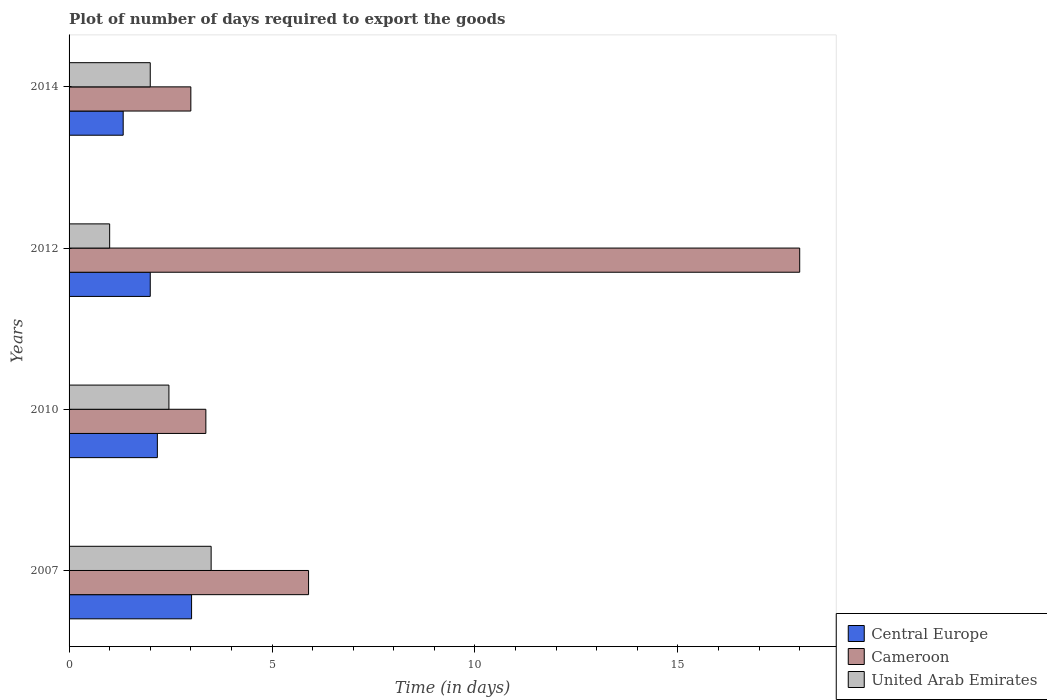Are the number of bars per tick equal to the number of legend labels?
Your response must be concise. Yes. How many bars are there on the 3rd tick from the top?
Your response must be concise. 3. How many bars are there on the 1st tick from the bottom?
Ensure brevity in your answer.  3. What is the label of the 1st group of bars from the top?
Offer a very short reply. 2014. In how many cases, is the number of bars for a given year not equal to the number of legend labels?
Provide a short and direct response. 0. What is the time required to export goods in Central Europe in 2010?
Your answer should be very brief. 2.17. In which year was the time required to export goods in Cameroon maximum?
Your answer should be compact. 2012. In which year was the time required to export goods in United Arab Emirates minimum?
Your answer should be compact. 2012. What is the total time required to export goods in United Arab Emirates in the graph?
Your response must be concise. 8.96. What is the difference between the time required to export goods in United Arab Emirates in 2007 and that in 2010?
Provide a succinct answer. 1.04. What is the difference between the time required to export goods in Central Europe in 2014 and the time required to export goods in Cameroon in 2007?
Keep it short and to the point. -4.57. What is the average time required to export goods in Central Europe per year?
Keep it short and to the point. 2.13. In the year 2014, what is the difference between the time required to export goods in Central Europe and time required to export goods in United Arab Emirates?
Your response must be concise. -0.67. What is the ratio of the time required to export goods in Cameroon in 2007 to that in 2010?
Provide a short and direct response. 1.75. Is the time required to export goods in Cameroon in 2010 less than that in 2012?
Your response must be concise. Yes. What is the difference between the highest and the second highest time required to export goods in United Arab Emirates?
Your answer should be compact. 1.04. What is the difference between the highest and the lowest time required to export goods in Cameroon?
Provide a succinct answer. 15. In how many years, is the time required to export goods in Cameroon greater than the average time required to export goods in Cameroon taken over all years?
Give a very brief answer. 1. What does the 3rd bar from the top in 2012 represents?
Your response must be concise. Central Europe. What does the 3rd bar from the bottom in 2014 represents?
Your response must be concise. United Arab Emirates. How many years are there in the graph?
Give a very brief answer. 4. Does the graph contain any zero values?
Keep it short and to the point. No. Does the graph contain grids?
Offer a very short reply. No. What is the title of the graph?
Offer a very short reply. Plot of number of days required to export the goods. Does "South Sudan" appear as one of the legend labels in the graph?
Offer a terse response. No. What is the label or title of the X-axis?
Offer a very short reply. Time (in days). What is the Time (in days) in Central Europe in 2007?
Your answer should be very brief. 3.02. What is the Time (in days) in Cameroon in 2007?
Keep it short and to the point. 5.9. What is the Time (in days) in Central Europe in 2010?
Your answer should be very brief. 2.17. What is the Time (in days) in Cameroon in 2010?
Keep it short and to the point. 3.37. What is the Time (in days) of United Arab Emirates in 2010?
Provide a short and direct response. 2.46. What is the Time (in days) of Central Europe in 2012?
Give a very brief answer. 2. What is the Time (in days) of Central Europe in 2014?
Provide a short and direct response. 1.33. What is the Time (in days) in Cameroon in 2014?
Your answer should be very brief. 3. Across all years, what is the maximum Time (in days) of Central Europe?
Your response must be concise. 3.02. Across all years, what is the maximum Time (in days) of Cameroon?
Give a very brief answer. 18. Across all years, what is the minimum Time (in days) in Central Europe?
Provide a short and direct response. 1.33. Across all years, what is the minimum Time (in days) of Cameroon?
Your answer should be very brief. 3. What is the total Time (in days) in Central Europe in the graph?
Offer a terse response. 8.53. What is the total Time (in days) in Cameroon in the graph?
Give a very brief answer. 30.27. What is the total Time (in days) of United Arab Emirates in the graph?
Your response must be concise. 8.96. What is the difference between the Time (in days) of Central Europe in 2007 and that in 2010?
Offer a terse response. 0.84. What is the difference between the Time (in days) of Cameroon in 2007 and that in 2010?
Offer a terse response. 2.53. What is the difference between the Time (in days) in United Arab Emirates in 2007 and that in 2010?
Your answer should be very brief. 1.04. What is the difference between the Time (in days) of Central Europe in 2007 and that in 2012?
Your response must be concise. 1.02. What is the difference between the Time (in days) in Central Europe in 2007 and that in 2014?
Make the answer very short. 1.68. What is the difference between the Time (in days) of Cameroon in 2007 and that in 2014?
Provide a succinct answer. 2.9. What is the difference between the Time (in days) in United Arab Emirates in 2007 and that in 2014?
Offer a very short reply. 1.5. What is the difference between the Time (in days) in Central Europe in 2010 and that in 2012?
Make the answer very short. 0.17. What is the difference between the Time (in days) in Cameroon in 2010 and that in 2012?
Your response must be concise. -14.63. What is the difference between the Time (in days) in United Arab Emirates in 2010 and that in 2012?
Offer a very short reply. 1.46. What is the difference between the Time (in days) of Central Europe in 2010 and that in 2014?
Ensure brevity in your answer.  0.84. What is the difference between the Time (in days) in Cameroon in 2010 and that in 2014?
Your response must be concise. 0.37. What is the difference between the Time (in days) of United Arab Emirates in 2010 and that in 2014?
Your answer should be very brief. 0.46. What is the difference between the Time (in days) of Central Europe in 2007 and the Time (in days) of Cameroon in 2010?
Offer a terse response. -0.35. What is the difference between the Time (in days) of Central Europe in 2007 and the Time (in days) of United Arab Emirates in 2010?
Provide a short and direct response. 0.56. What is the difference between the Time (in days) in Cameroon in 2007 and the Time (in days) in United Arab Emirates in 2010?
Keep it short and to the point. 3.44. What is the difference between the Time (in days) of Central Europe in 2007 and the Time (in days) of Cameroon in 2012?
Provide a short and direct response. -14.98. What is the difference between the Time (in days) of Central Europe in 2007 and the Time (in days) of United Arab Emirates in 2012?
Ensure brevity in your answer.  2.02. What is the difference between the Time (in days) in Central Europe in 2007 and the Time (in days) in Cameroon in 2014?
Provide a short and direct response. 0.02. What is the difference between the Time (in days) in Central Europe in 2007 and the Time (in days) in United Arab Emirates in 2014?
Your answer should be very brief. 1.02. What is the difference between the Time (in days) of Cameroon in 2007 and the Time (in days) of United Arab Emirates in 2014?
Keep it short and to the point. 3.9. What is the difference between the Time (in days) of Central Europe in 2010 and the Time (in days) of Cameroon in 2012?
Give a very brief answer. -15.82. What is the difference between the Time (in days) of Central Europe in 2010 and the Time (in days) of United Arab Emirates in 2012?
Your answer should be very brief. 1.18. What is the difference between the Time (in days) of Cameroon in 2010 and the Time (in days) of United Arab Emirates in 2012?
Make the answer very short. 2.37. What is the difference between the Time (in days) in Central Europe in 2010 and the Time (in days) in Cameroon in 2014?
Keep it short and to the point. -0.82. What is the difference between the Time (in days) in Central Europe in 2010 and the Time (in days) in United Arab Emirates in 2014?
Give a very brief answer. 0.17. What is the difference between the Time (in days) of Cameroon in 2010 and the Time (in days) of United Arab Emirates in 2014?
Provide a short and direct response. 1.37. What is the difference between the Time (in days) in Central Europe in 2012 and the Time (in days) in Cameroon in 2014?
Keep it short and to the point. -1. What is the average Time (in days) in Central Europe per year?
Provide a succinct answer. 2.13. What is the average Time (in days) in Cameroon per year?
Your answer should be very brief. 7.57. What is the average Time (in days) of United Arab Emirates per year?
Provide a succinct answer. 2.24. In the year 2007, what is the difference between the Time (in days) in Central Europe and Time (in days) in Cameroon?
Your response must be concise. -2.88. In the year 2007, what is the difference between the Time (in days) in Central Europe and Time (in days) in United Arab Emirates?
Offer a very short reply. -0.48. In the year 2007, what is the difference between the Time (in days) of Cameroon and Time (in days) of United Arab Emirates?
Make the answer very short. 2.4. In the year 2010, what is the difference between the Time (in days) of Central Europe and Time (in days) of Cameroon?
Offer a very short reply. -1.2. In the year 2010, what is the difference between the Time (in days) in Central Europe and Time (in days) in United Arab Emirates?
Your answer should be very brief. -0.28. In the year 2010, what is the difference between the Time (in days) in Cameroon and Time (in days) in United Arab Emirates?
Offer a very short reply. 0.91. In the year 2012, what is the difference between the Time (in days) of Central Europe and Time (in days) of Cameroon?
Your answer should be very brief. -16. In the year 2012, what is the difference between the Time (in days) in Cameroon and Time (in days) in United Arab Emirates?
Your answer should be compact. 17. In the year 2014, what is the difference between the Time (in days) in Central Europe and Time (in days) in Cameroon?
Keep it short and to the point. -1.67. What is the ratio of the Time (in days) of Central Europe in 2007 to that in 2010?
Give a very brief answer. 1.39. What is the ratio of the Time (in days) of Cameroon in 2007 to that in 2010?
Your answer should be very brief. 1.75. What is the ratio of the Time (in days) in United Arab Emirates in 2007 to that in 2010?
Offer a very short reply. 1.42. What is the ratio of the Time (in days) of Central Europe in 2007 to that in 2012?
Make the answer very short. 1.51. What is the ratio of the Time (in days) in Cameroon in 2007 to that in 2012?
Offer a terse response. 0.33. What is the ratio of the Time (in days) of Central Europe in 2007 to that in 2014?
Your response must be concise. 2.26. What is the ratio of the Time (in days) of Cameroon in 2007 to that in 2014?
Make the answer very short. 1.97. What is the ratio of the Time (in days) of United Arab Emirates in 2007 to that in 2014?
Your answer should be compact. 1.75. What is the ratio of the Time (in days) of Central Europe in 2010 to that in 2012?
Your answer should be very brief. 1.09. What is the ratio of the Time (in days) of Cameroon in 2010 to that in 2012?
Keep it short and to the point. 0.19. What is the ratio of the Time (in days) of United Arab Emirates in 2010 to that in 2012?
Give a very brief answer. 2.46. What is the ratio of the Time (in days) of Central Europe in 2010 to that in 2014?
Keep it short and to the point. 1.63. What is the ratio of the Time (in days) in Cameroon in 2010 to that in 2014?
Your answer should be compact. 1.12. What is the ratio of the Time (in days) of United Arab Emirates in 2010 to that in 2014?
Your answer should be very brief. 1.23. What is the ratio of the Time (in days) in Cameroon in 2012 to that in 2014?
Provide a succinct answer. 6. What is the ratio of the Time (in days) of United Arab Emirates in 2012 to that in 2014?
Offer a very short reply. 0.5. What is the difference between the highest and the second highest Time (in days) in Central Europe?
Ensure brevity in your answer.  0.84. What is the difference between the highest and the second highest Time (in days) of Cameroon?
Give a very brief answer. 12.1. What is the difference between the highest and the lowest Time (in days) in Central Europe?
Your response must be concise. 1.68. What is the difference between the highest and the lowest Time (in days) of United Arab Emirates?
Provide a succinct answer. 2.5. 